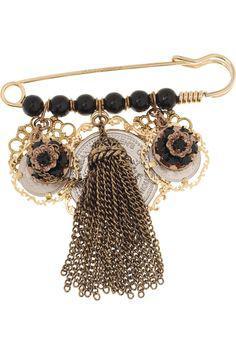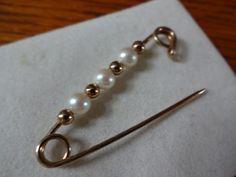The first image is the image on the left, the second image is the image on the right. Assess this claim about the two images: "The right image shows only one decorated pin.". Correct or not? Answer yes or no. Yes. 